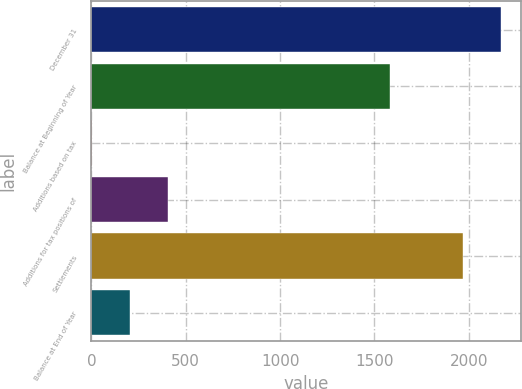Convert chart. <chart><loc_0><loc_0><loc_500><loc_500><bar_chart><fcel>December 31<fcel>Balance at Beginning of Year<fcel>Additions based on tax<fcel>Additions for tax positions of<fcel>Settlements<fcel>Balance at End of Year<nl><fcel>2169.1<fcel>1581<fcel>1.97<fcel>404.17<fcel>1968<fcel>203.07<nl></chart> 